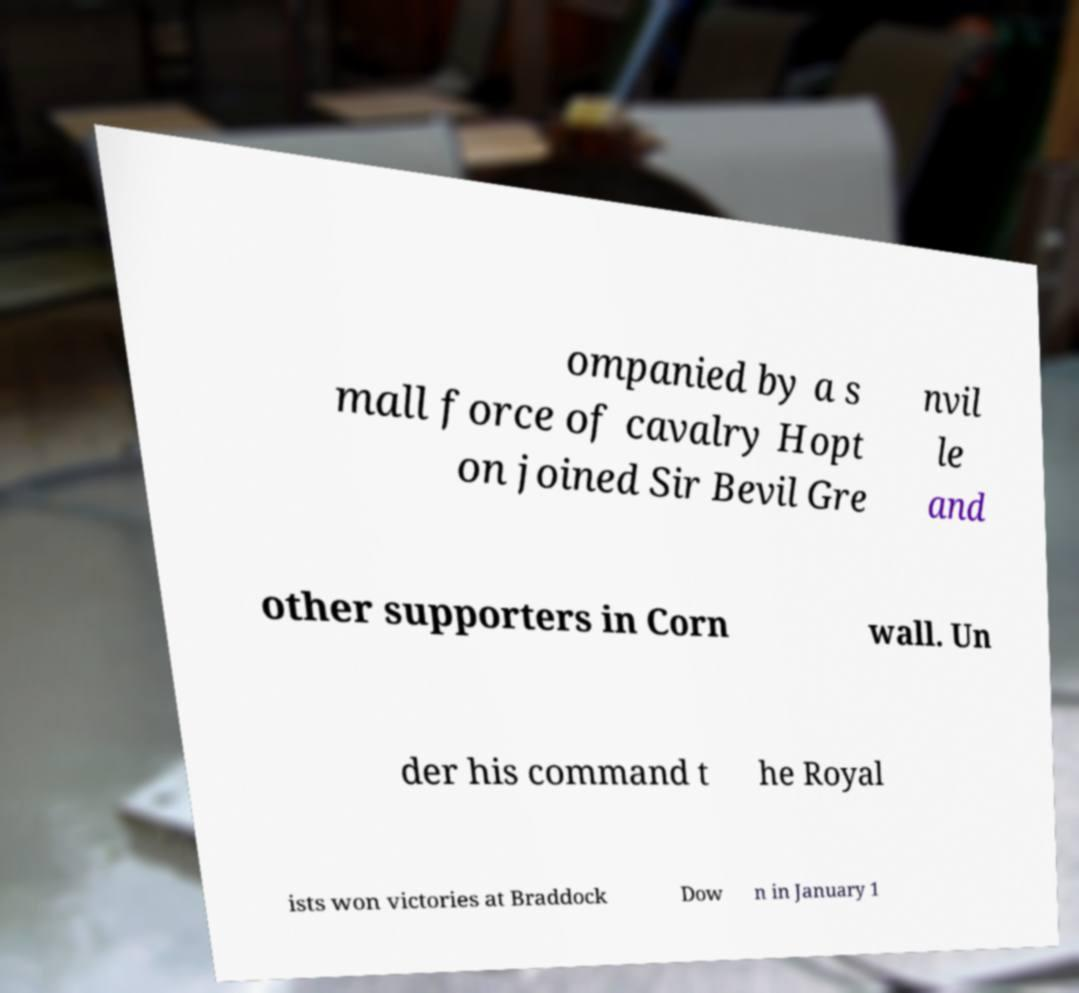Can you accurately transcribe the text from the provided image for me? ompanied by a s mall force of cavalry Hopt on joined Sir Bevil Gre nvil le and other supporters in Corn wall. Un der his command t he Royal ists won victories at Braddock Dow n in January 1 